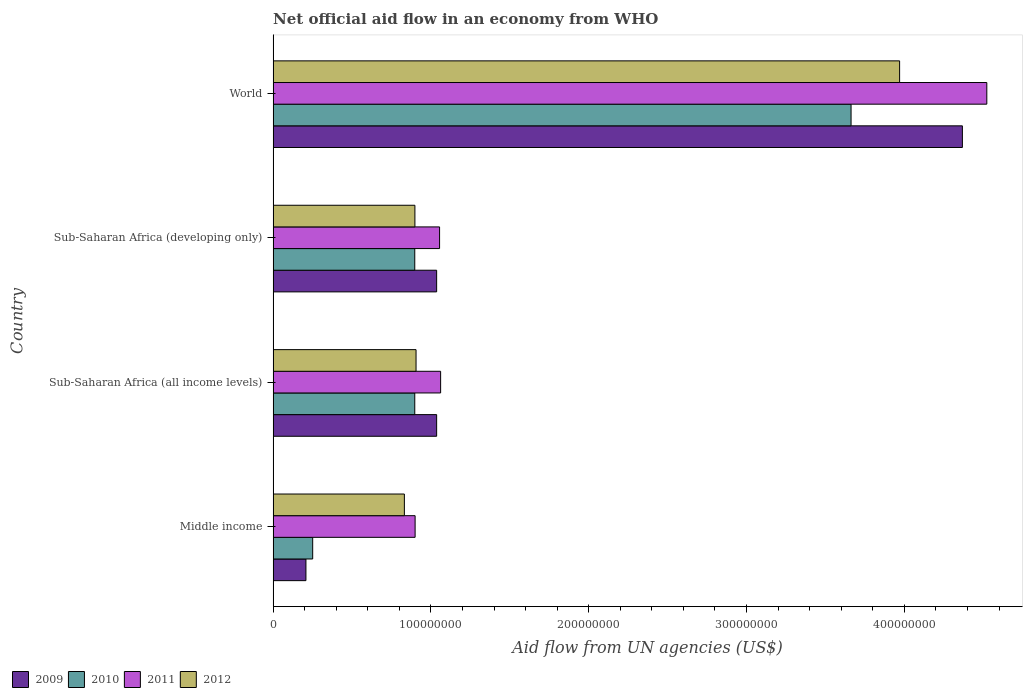How many different coloured bars are there?
Provide a succinct answer. 4. How many bars are there on the 2nd tick from the top?
Provide a succinct answer. 4. What is the label of the 4th group of bars from the top?
Provide a short and direct response. Middle income. In how many cases, is the number of bars for a given country not equal to the number of legend labels?
Your response must be concise. 0. What is the net official aid flow in 2009 in Sub-Saharan Africa (all income levels)?
Your answer should be very brief. 1.04e+08. Across all countries, what is the maximum net official aid flow in 2009?
Provide a succinct answer. 4.37e+08. Across all countries, what is the minimum net official aid flow in 2012?
Ensure brevity in your answer.  8.32e+07. In which country was the net official aid flow in 2010 maximum?
Provide a short and direct response. World. What is the total net official aid flow in 2012 in the graph?
Ensure brevity in your answer.  6.61e+08. What is the difference between the net official aid flow in 2011 in Sub-Saharan Africa (developing only) and the net official aid flow in 2012 in World?
Ensure brevity in your answer.  -2.92e+08. What is the average net official aid flow in 2010 per country?
Your response must be concise. 1.43e+08. What is the difference between the net official aid flow in 2010 and net official aid flow in 2012 in Middle income?
Your answer should be very brief. -5.81e+07. What is the ratio of the net official aid flow in 2010 in Sub-Saharan Africa (developing only) to that in World?
Ensure brevity in your answer.  0.25. What is the difference between the highest and the second highest net official aid flow in 2009?
Offer a very short reply. 3.33e+08. What is the difference between the highest and the lowest net official aid flow in 2012?
Your answer should be very brief. 3.14e+08. In how many countries, is the net official aid flow in 2010 greater than the average net official aid flow in 2010 taken over all countries?
Ensure brevity in your answer.  1. Is the sum of the net official aid flow in 2012 in Middle income and World greater than the maximum net official aid flow in 2011 across all countries?
Provide a succinct answer. Yes. Are all the bars in the graph horizontal?
Provide a short and direct response. Yes. Are the values on the major ticks of X-axis written in scientific E-notation?
Ensure brevity in your answer.  No. Does the graph contain any zero values?
Your answer should be compact. No. Does the graph contain grids?
Give a very brief answer. No. Where does the legend appear in the graph?
Give a very brief answer. Bottom left. How many legend labels are there?
Your answer should be compact. 4. What is the title of the graph?
Offer a very short reply. Net official aid flow in an economy from WHO. Does "1962" appear as one of the legend labels in the graph?
Make the answer very short. No. What is the label or title of the X-axis?
Ensure brevity in your answer.  Aid flow from UN agencies (US$). What is the label or title of the Y-axis?
Offer a very short reply. Country. What is the Aid flow from UN agencies (US$) in 2009 in Middle income?
Ensure brevity in your answer.  2.08e+07. What is the Aid flow from UN agencies (US$) of 2010 in Middle income?
Your response must be concise. 2.51e+07. What is the Aid flow from UN agencies (US$) in 2011 in Middle income?
Keep it short and to the point. 9.00e+07. What is the Aid flow from UN agencies (US$) of 2012 in Middle income?
Provide a succinct answer. 8.32e+07. What is the Aid flow from UN agencies (US$) in 2009 in Sub-Saharan Africa (all income levels)?
Provide a succinct answer. 1.04e+08. What is the Aid flow from UN agencies (US$) in 2010 in Sub-Saharan Africa (all income levels)?
Ensure brevity in your answer.  8.98e+07. What is the Aid flow from UN agencies (US$) of 2011 in Sub-Saharan Africa (all income levels)?
Your answer should be very brief. 1.06e+08. What is the Aid flow from UN agencies (US$) in 2012 in Sub-Saharan Africa (all income levels)?
Your response must be concise. 9.06e+07. What is the Aid flow from UN agencies (US$) in 2009 in Sub-Saharan Africa (developing only)?
Keep it short and to the point. 1.04e+08. What is the Aid flow from UN agencies (US$) in 2010 in Sub-Saharan Africa (developing only)?
Keep it short and to the point. 8.98e+07. What is the Aid flow from UN agencies (US$) of 2011 in Sub-Saharan Africa (developing only)?
Your response must be concise. 1.05e+08. What is the Aid flow from UN agencies (US$) in 2012 in Sub-Saharan Africa (developing only)?
Keep it short and to the point. 8.98e+07. What is the Aid flow from UN agencies (US$) in 2009 in World?
Provide a short and direct response. 4.37e+08. What is the Aid flow from UN agencies (US$) in 2010 in World?
Make the answer very short. 3.66e+08. What is the Aid flow from UN agencies (US$) in 2011 in World?
Keep it short and to the point. 4.52e+08. What is the Aid flow from UN agencies (US$) in 2012 in World?
Provide a short and direct response. 3.97e+08. Across all countries, what is the maximum Aid flow from UN agencies (US$) of 2009?
Give a very brief answer. 4.37e+08. Across all countries, what is the maximum Aid flow from UN agencies (US$) in 2010?
Ensure brevity in your answer.  3.66e+08. Across all countries, what is the maximum Aid flow from UN agencies (US$) in 2011?
Keep it short and to the point. 4.52e+08. Across all countries, what is the maximum Aid flow from UN agencies (US$) in 2012?
Your response must be concise. 3.97e+08. Across all countries, what is the minimum Aid flow from UN agencies (US$) in 2009?
Provide a short and direct response. 2.08e+07. Across all countries, what is the minimum Aid flow from UN agencies (US$) in 2010?
Offer a very short reply. 2.51e+07. Across all countries, what is the minimum Aid flow from UN agencies (US$) of 2011?
Provide a succinct answer. 9.00e+07. Across all countries, what is the minimum Aid flow from UN agencies (US$) of 2012?
Your response must be concise. 8.32e+07. What is the total Aid flow from UN agencies (US$) in 2009 in the graph?
Your answer should be very brief. 6.65e+08. What is the total Aid flow from UN agencies (US$) in 2010 in the graph?
Offer a terse response. 5.71e+08. What is the total Aid flow from UN agencies (US$) in 2011 in the graph?
Offer a terse response. 7.54e+08. What is the total Aid flow from UN agencies (US$) of 2012 in the graph?
Provide a succinct answer. 6.61e+08. What is the difference between the Aid flow from UN agencies (US$) in 2009 in Middle income and that in Sub-Saharan Africa (all income levels)?
Offer a very short reply. -8.28e+07. What is the difference between the Aid flow from UN agencies (US$) of 2010 in Middle income and that in Sub-Saharan Africa (all income levels)?
Your answer should be compact. -6.47e+07. What is the difference between the Aid flow from UN agencies (US$) in 2011 in Middle income and that in Sub-Saharan Africa (all income levels)?
Ensure brevity in your answer.  -1.62e+07. What is the difference between the Aid flow from UN agencies (US$) of 2012 in Middle income and that in Sub-Saharan Africa (all income levels)?
Your answer should be very brief. -7.39e+06. What is the difference between the Aid flow from UN agencies (US$) in 2009 in Middle income and that in Sub-Saharan Africa (developing only)?
Your response must be concise. -8.28e+07. What is the difference between the Aid flow from UN agencies (US$) in 2010 in Middle income and that in Sub-Saharan Africa (developing only)?
Your answer should be compact. -6.47e+07. What is the difference between the Aid flow from UN agencies (US$) in 2011 in Middle income and that in Sub-Saharan Africa (developing only)?
Your answer should be compact. -1.55e+07. What is the difference between the Aid flow from UN agencies (US$) of 2012 in Middle income and that in Sub-Saharan Africa (developing only)?
Your response must be concise. -6.67e+06. What is the difference between the Aid flow from UN agencies (US$) of 2009 in Middle income and that in World?
Ensure brevity in your answer.  -4.16e+08. What is the difference between the Aid flow from UN agencies (US$) of 2010 in Middle income and that in World?
Ensure brevity in your answer.  -3.41e+08. What is the difference between the Aid flow from UN agencies (US$) in 2011 in Middle income and that in World?
Ensure brevity in your answer.  -3.62e+08. What is the difference between the Aid flow from UN agencies (US$) in 2012 in Middle income and that in World?
Give a very brief answer. -3.14e+08. What is the difference between the Aid flow from UN agencies (US$) of 2011 in Sub-Saharan Africa (all income levels) and that in Sub-Saharan Africa (developing only)?
Provide a short and direct response. 6.70e+05. What is the difference between the Aid flow from UN agencies (US$) in 2012 in Sub-Saharan Africa (all income levels) and that in Sub-Saharan Africa (developing only)?
Your answer should be compact. 7.20e+05. What is the difference between the Aid flow from UN agencies (US$) of 2009 in Sub-Saharan Africa (all income levels) and that in World?
Ensure brevity in your answer.  -3.33e+08. What is the difference between the Aid flow from UN agencies (US$) of 2010 in Sub-Saharan Africa (all income levels) and that in World?
Offer a terse response. -2.76e+08. What is the difference between the Aid flow from UN agencies (US$) in 2011 in Sub-Saharan Africa (all income levels) and that in World?
Ensure brevity in your answer.  -3.46e+08. What is the difference between the Aid flow from UN agencies (US$) in 2012 in Sub-Saharan Africa (all income levels) and that in World?
Make the answer very short. -3.06e+08. What is the difference between the Aid flow from UN agencies (US$) of 2009 in Sub-Saharan Africa (developing only) and that in World?
Offer a terse response. -3.33e+08. What is the difference between the Aid flow from UN agencies (US$) in 2010 in Sub-Saharan Africa (developing only) and that in World?
Offer a very short reply. -2.76e+08. What is the difference between the Aid flow from UN agencies (US$) of 2011 in Sub-Saharan Africa (developing only) and that in World?
Ensure brevity in your answer.  -3.47e+08. What is the difference between the Aid flow from UN agencies (US$) of 2012 in Sub-Saharan Africa (developing only) and that in World?
Make the answer very short. -3.07e+08. What is the difference between the Aid flow from UN agencies (US$) of 2009 in Middle income and the Aid flow from UN agencies (US$) of 2010 in Sub-Saharan Africa (all income levels)?
Your answer should be compact. -6.90e+07. What is the difference between the Aid flow from UN agencies (US$) of 2009 in Middle income and the Aid flow from UN agencies (US$) of 2011 in Sub-Saharan Africa (all income levels)?
Offer a terse response. -8.54e+07. What is the difference between the Aid flow from UN agencies (US$) in 2009 in Middle income and the Aid flow from UN agencies (US$) in 2012 in Sub-Saharan Africa (all income levels)?
Ensure brevity in your answer.  -6.98e+07. What is the difference between the Aid flow from UN agencies (US$) in 2010 in Middle income and the Aid flow from UN agencies (US$) in 2011 in Sub-Saharan Africa (all income levels)?
Give a very brief answer. -8.11e+07. What is the difference between the Aid flow from UN agencies (US$) in 2010 in Middle income and the Aid flow from UN agencies (US$) in 2012 in Sub-Saharan Africa (all income levels)?
Keep it short and to the point. -6.55e+07. What is the difference between the Aid flow from UN agencies (US$) of 2011 in Middle income and the Aid flow from UN agencies (US$) of 2012 in Sub-Saharan Africa (all income levels)?
Your answer should be very brief. -5.90e+05. What is the difference between the Aid flow from UN agencies (US$) in 2009 in Middle income and the Aid flow from UN agencies (US$) in 2010 in Sub-Saharan Africa (developing only)?
Give a very brief answer. -6.90e+07. What is the difference between the Aid flow from UN agencies (US$) in 2009 in Middle income and the Aid flow from UN agencies (US$) in 2011 in Sub-Saharan Africa (developing only)?
Offer a very short reply. -8.47e+07. What is the difference between the Aid flow from UN agencies (US$) in 2009 in Middle income and the Aid flow from UN agencies (US$) in 2012 in Sub-Saharan Africa (developing only)?
Keep it short and to the point. -6.90e+07. What is the difference between the Aid flow from UN agencies (US$) of 2010 in Middle income and the Aid flow from UN agencies (US$) of 2011 in Sub-Saharan Africa (developing only)?
Provide a succinct answer. -8.04e+07. What is the difference between the Aid flow from UN agencies (US$) in 2010 in Middle income and the Aid flow from UN agencies (US$) in 2012 in Sub-Saharan Africa (developing only)?
Offer a terse response. -6.48e+07. What is the difference between the Aid flow from UN agencies (US$) of 2011 in Middle income and the Aid flow from UN agencies (US$) of 2012 in Sub-Saharan Africa (developing only)?
Your answer should be very brief. 1.30e+05. What is the difference between the Aid flow from UN agencies (US$) of 2009 in Middle income and the Aid flow from UN agencies (US$) of 2010 in World?
Provide a short and direct response. -3.45e+08. What is the difference between the Aid flow from UN agencies (US$) of 2009 in Middle income and the Aid flow from UN agencies (US$) of 2011 in World?
Ensure brevity in your answer.  -4.31e+08. What is the difference between the Aid flow from UN agencies (US$) in 2009 in Middle income and the Aid flow from UN agencies (US$) in 2012 in World?
Your answer should be very brief. -3.76e+08. What is the difference between the Aid flow from UN agencies (US$) in 2010 in Middle income and the Aid flow from UN agencies (US$) in 2011 in World?
Offer a very short reply. -4.27e+08. What is the difference between the Aid flow from UN agencies (US$) of 2010 in Middle income and the Aid flow from UN agencies (US$) of 2012 in World?
Your response must be concise. -3.72e+08. What is the difference between the Aid flow from UN agencies (US$) in 2011 in Middle income and the Aid flow from UN agencies (US$) in 2012 in World?
Make the answer very short. -3.07e+08. What is the difference between the Aid flow from UN agencies (US$) in 2009 in Sub-Saharan Africa (all income levels) and the Aid flow from UN agencies (US$) in 2010 in Sub-Saharan Africa (developing only)?
Your answer should be compact. 1.39e+07. What is the difference between the Aid flow from UN agencies (US$) of 2009 in Sub-Saharan Africa (all income levels) and the Aid flow from UN agencies (US$) of 2011 in Sub-Saharan Africa (developing only)?
Provide a short and direct response. -1.86e+06. What is the difference between the Aid flow from UN agencies (US$) in 2009 in Sub-Saharan Africa (all income levels) and the Aid flow from UN agencies (US$) in 2012 in Sub-Saharan Africa (developing only)?
Keep it short and to the point. 1.38e+07. What is the difference between the Aid flow from UN agencies (US$) of 2010 in Sub-Saharan Africa (all income levels) and the Aid flow from UN agencies (US$) of 2011 in Sub-Saharan Africa (developing only)?
Provide a short and direct response. -1.57e+07. What is the difference between the Aid flow from UN agencies (US$) in 2011 in Sub-Saharan Africa (all income levels) and the Aid flow from UN agencies (US$) in 2012 in Sub-Saharan Africa (developing only)?
Make the answer very short. 1.63e+07. What is the difference between the Aid flow from UN agencies (US$) of 2009 in Sub-Saharan Africa (all income levels) and the Aid flow from UN agencies (US$) of 2010 in World?
Your response must be concise. -2.63e+08. What is the difference between the Aid flow from UN agencies (US$) in 2009 in Sub-Saharan Africa (all income levels) and the Aid flow from UN agencies (US$) in 2011 in World?
Your answer should be very brief. -3.49e+08. What is the difference between the Aid flow from UN agencies (US$) in 2009 in Sub-Saharan Africa (all income levels) and the Aid flow from UN agencies (US$) in 2012 in World?
Provide a succinct answer. -2.93e+08. What is the difference between the Aid flow from UN agencies (US$) of 2010 in Sub-Saharan Africa (all income levels) and the Aid flow from UN agencies (US$) of 2011 in World?
Provide a short and direct response. -3.62e+08. What is the difference between the Aid flow from UN agencies (US$) in 2010 in Sub-Saharan Africa (all income levels) and the Aid flow from UN agencies (US$) in 2012 in World?
Your answer should be compact. -3.07e+08. What is the difference between the Aid flow from UN agencies (US$) of 2011 in Sub-Saharan Africa (all income levels) and the Aid flow from UN agencies (US$) of 2012 in World?
Offer a very short reply. -2.91e+08. What is the difference between the Aid flow from UN agencies (US$) of 2009 in Sub-Saharan Africa (developing only) and the Aid flow from UN agencies (US$) of 2010 in World?
Your answer should be compact. -2.63e+08. What is the difference between the Aid flow from UN agencies (US$) of 2009 in Sub-Saharan Africa (developing only) and the Aid flow from UN agencies (US$) of 2011 in World?
Keep it short and to the point. -3.49e+08. What is the difference between the Aid flow from UN agencies (US$) of 2009 in Sub-Saharan Africa (developing only) and the Aid flow from UN agencies (US$) of 2012 in World?
Your answer should be very brief. -2.93e+08. What is the difference between the Aid flow from UN agencies (US$) in 2010 in Sub-Saharan Africa (developing only) and the Aid flow from UN agencies (US$) in 2011 in World?
Provide a short and direct response. -3.62e+08. What is the difference between the Aid flow from UN agencies (US$) in 2010 in Sub-Saharan Africa (developing only) and the Aid flow from UN agencies (US$) in 2012 in World?
Your answer should be very brief. -3.07e+08. What is the difference between the Aid flow from UN agencies (US$) of 2011 in Sub-Saharan Africa (developing only) and the Aid flow from UN agencies (US$) of 2012 in World?
Offer a very short reply. -2.92e+08. What is the average Aid flow from UN agencies (US$) in 2009 per country?
Give a very brief answer. 1.66e+08. What is the average Aid flow from UN agencies (US$) of 2010 per country?
Give a very brief answer. 1.43e+08. What is the average Aid flow from UN agencies (US$) in 2011 per country?
Your response must be concise. 1.88e+08. What is the average Aid flow from UN agencies (US$) of 2012 per country?
Provide a short and direct response. 1.65e+08. What is the difference between the Aid flow from UN agencies (US$) of 2009 and Aid flow from UN agencies (US$) of 2010 in Middle income?
Provide a short and direct response. -4.27e+06. What is the difference between the Aid flow from UN agencies (US$) of 2009 and Aid flow from UN agencies (US$) of 2011 in Middle income?
Offer a terse response. -6.92e+07. What is the difference between the Aid flow from UN agencies (US$) of 2009 and Aid flow from UN agencies (US$) of 2012 in Middle income?
Offer a terse response. -6.24e+07. What is the difference between the Aid flow from UN agencies (US$) of 2010 and Aid flow from UN agencies (US$) of 2011 in Middle income?
Provide a succinct answer. -6.49e+07. What is the difference between the Aid flow from UN agencies (US$) in 2010 and Aid flow from UN agencies (US$) in 2012 in Middle income?
Offer a very short reply. -5.81e+07. What is the difference between the Aid flow from UN agencies (US$) in 2011 and Aid flow from UN agencies (US$) in 2012 in Middle income?
Provide a short and direct response. 6.80e+06. What is the difference between the Aid flow from UN agencies (US$) of 2009 and Aid flow from UN agencies (US$) of 2010 in Sub-Saharan Africa (all income levels)?
Make the answer very short. 1.39e+07. What is the difference between the Aid flow from UN agencies (US$) in 2009 and Aid flow from UN agencies (US$) in 2011 in Sub-Saharan Africa (all income levels)?
Offer a terse response. -2.53e+06. What is the difference between the Aid flow from UN agencies (US$) in 2009 and Aid flow from UN agencies (US$) in 2012 in Sub-Saharan Africa (all income levels)?
Offer a terse response. 1.30e+07. What is the difference between the Aid flow from UN agencies (US$) in 2010 and Aid flow from UN agencies (US$) in 2011 in Sub-Saharan Africa (all income levels)?
Your response must be concise. -1.64e+07. What is the difference between the Aid flow from UN agencies (US$) of 2010 and Aid flow from UN agencies (US$) of 2012 in Sub-Saharan Africa (all income levels)?
Offer a terse response. -8.10e+05. What is the difference between the Aid flow from UN agencies (US$) of 2011 and Aid flow from UN agencies (US$) of 2012 in Sub-Saharan Africa (all income levels)?
Keep it short and to the point. 1.56e+07. What is the difference between the Aid flow from UN agencies (US$) in 2009 and Aid flow from UN agencies (US$) in 2010 in Sub-Saharan Africa (developing only)?
Offer a terse response. 1.39e+07. What is the difference between the Aid flow from UN agencies (US$) in 2009 and Aid flow from UN agencies (US$) in 2011 in Sub-Saharan Africa (developing only)?
Your answer should be compact. -1.86e+06. What is the difference between the Aid flow from UN agencies (US$) in 2009 and Aid flow from UN agencies (US$) in 2012 in Sub-Saharan Africa (developing only)?
Keep it short and to the point. 1.38e+07. What is the difference between the Aid flow from UN agencies (US$) of 2010 and Aid flow from UN agencies (US$) of 2011 in Sub-Saharan Africa (developing only)?
Your response must be concise. -1.57e+07. What is the difference between the Aid flow from UN agencies (US$) in 2010 and Aid flow from UN agencies (US$) in 2012 in Sub-Saharan Africa (developing only)?
Ensure brevity in your answer.  -9.00e+04. What is the difference between the Aid flow from UN agencies (US$) of 2011 and Aid flow from UN agencies (US$) of 2012 in Sub-Saharan Africa (developing only)?
Your answer should be compact. 1.56e+07. What is the difference between the Aid flow from UN agencies (US$) of 2009 and Aid flow from UN agencies (US$) of 2010 in World?
Make the answer very short. 7.06e+07. What is the difference between the Aid flow from UN agencies (US$) of 2009 and Aid flow from UN agencies (US$) of 2011 in World?
Ensure brevity in your answer.  -1.55e+07. What is the difference between the Aid flow from UN agencies (US$) of 2009 and Aid flow from UN agencies (US$) of 2012 in World?
Make the answer very short. 3.98e+07. What is the difference between the Aid flow from UN agencies (US$) in 2010 and Aid flow from UN agencies (US$) in 2011 in World?
Ensure brevity in your answer.  -8.60e+07. What is the difference between the Aid flow from UN agencies (US$) of 2010 and Aid flow from UN agencies (US$) of 2012 in World?
Provide a short and direct response. -3.08e+07. What is the difference between the Aid flow from UN agencies (US$) of 2011 and Aid flow from UN agencies (US$) of 2012 in World?
Your answer should be compact. 5.53e+07. What is the ratio of the Aid flow from UN agencies (US$) of 2009 in Middle income to that in Sub-Saharan Africa (all income levels)?
Ensure brevity in your answer.  0.2. What is the ratio of the Aid flow from UN agencies (US$) in 2010 in Middle income to that in Sub-Saharan Africa (all income levels)?
Ensure brevity in your answer.  0.28. What is the ratio of the Aid flow from UN agencies (US$) of 2011 in Middle income to that in Sub-Saharan Africa (all income levels)?
Ensure brevity in your answer.  0.85. What is the ratio of the Aid flow from UN agencies (US$) in 2012 in Middle income to that in Sub-Saharan Africa (all income levels)?
Offer a terse response. 0.92. What is the ratio of the Aid flow from UN agencies (US$) in 2009 in Middle income to that in Sub-Saharan Africa (developing only)?
Give a very brief answer. 0.2. What is the ratio of the Aid flow from UN agencies (US$) in 2010 in Middle income to that in Sub-Saharan Africa (developing only)?
Provide a succinct answer. 0.28. What is the ratio of the Aid flow from UN agencies (US$) of 2011 in Middle income to that in Sub-Saharan Africa (developing only)?
Give a very brief answer. 0.85. What is the ratio of the Aid flow from UN agencies (US$) of 2012 in Middle income to that in Sub-Saharan Africa (developing only)?
Make the answer very short. 0.93. What is the ratio of the Aid flow from UN agencies (US$) in 2009 in Middle income to that in World?
Your answer should be compact. 0.05. What is the ratio of the Aid flow from UN agencies (US$) of 2010 in Middle income to that in World?
Keep it short and to the point. 0.07. What is the ratio of the Aid flow from UN agencies (US$) of 2011 in Middle income to that in World?
Offer a very short reply. 0.2. What is the ratio of the Aid flow from UN agencies (US$) of 2012 in Middle income to that in World?
Your answer should be compact. 0.21. What is the ratio of the Aid flow from UN agencies (US$) in 2009 in Sub-Saharan Africa (all income levels) to that in Sub-Saharan Africa (developing only)?
Your response must be concise. 1. What is the ratio of the Aid flow from UN agencies (US$) in 2010 in Sub-Saharan Africa (all income levels) to that in Sub-Saharan Africa (developing only)?
Ensure brevity in your answer.  1. What is the ratio of the Aid flow from UN agencies (US$) of 2011 in Sub-Saharan Africa (all income levels) to that in Sub-Saharan Africa (developing only)?
Your answer should be compact. 1.01. What is the ratio of the Aid flow from UN agencies (US$) in 2012 in Sub-Saharan Africa (all income levels) to that in Sub-Saharan Africa (developing only)?
Provide a short and direct response. 1.01. What is the ratio of the Aid flow from UN agencies (US$) of 2009 in Sub-Saharan Africa (all income levels) to that in World?
Provide a short and direct response. 0.24. What is the ratio of the Aid flow from UN agencies (US$) in 2010 in Sub-Saharan Africa (all income levels) to that in World?
Provide a short and direct response. 0.25. What is the ratio of the Aid flow from UN agencies (US$) in 2011 in Sub-Saharan Africa (all income levels) to that in World?
Your response must be concise. 0.23. What is the ratio of the Aid flow from UN agencies (US$) in 2012 in Sub-Saharan Africa (all income levels) to that in World?
Provide a short and direct response. 0.23. What is the ratio of the Aid flow from UN agencies (US$) in 2009 in Sub-Saharan Africa (developing only) to that in World?
Your answer should be compact. 0.24. What is the ratio of the Aid flow from UN agencies (US$) of 2010 in Sub-Saharan Africa (developing only) to that in World?
Your answer should be very brief. 0.25. What is the ratio of the Aid flow from UN agencies (US$) of 2011 in Sub-Saharan Africa (developing only) to that in World?
Offer a very short reply. 0.23. What is the ratio of the Aid flow from UN agencies (US$) in 2012 in Sub-Saharan Africa (developing only) to that in World?
Keep it short and to the point. 0.23. What is the difference between the highest and the second highest Aid flow from UN agencies (US$) in 2009?
Ensure brevity in your answer.  3.33e+08. What is the difference between the highest and the second highest Aid flow from UN agencies (US$) of 2010?
Your answer should be very brief. 2.76e+08. What is the difference between the highest and the second highest Aid flow from UN agencies (US$) in 2011?
Provide a succinct answer. 3.46e+08. What is the difference between the highest and the second highest Aid flow from UN agencies (US$) of 2012?
Offer a very short reply. 3.06e+08. What is the difference between the highest and the lowest Aid flow from UN agencies (US$) of 2009?
Offer a terse response. 4.16e+08. What is the difference between the highest and the lowest Aid flow from UN agencies (US$) of 2010?
Keep it short and to the point. 3.41e+08. What is the difference between the highest and the lowest Aid flow from UN agencies (US$) of 2011?
Provide a short and direct response. 3.62e+08. What is the difference between the highest and the lowest Aid flow from UN agencies (US$) in 2012?
Offer a terse response. 3.14e+08. 